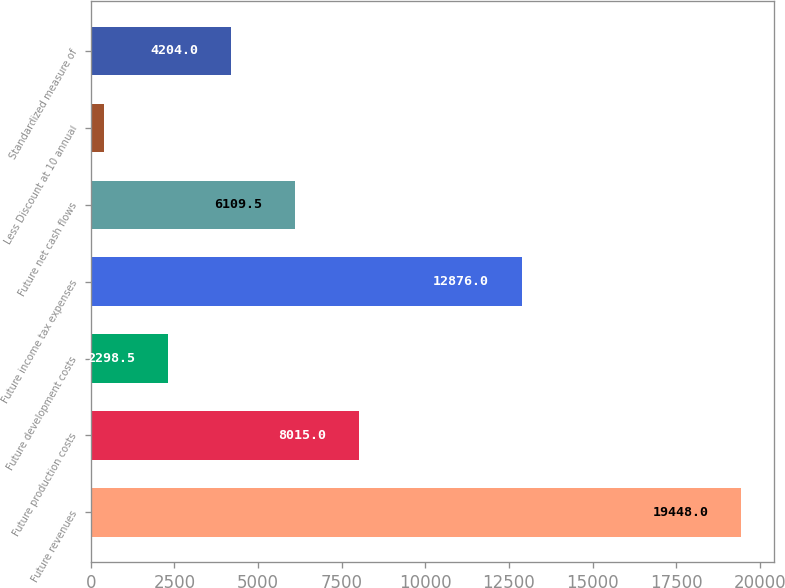Convert chart. <chart><loc_0><loc_0><loc_500><loc_500><bar_chart><fcel>Future revenues<fcel>Future production costs<fcel>Future development costs<fcel>Future income tax expenses<fcel>Future net cash flows<fcel>Less Discount at 10 annual<fcel>Standardized measure of<nl><fcel>19448<fcel>8015<fcel>2298.5<fcel>12876<fcel>6109.5<fcel>393<fcel>4204<nl></chart> 